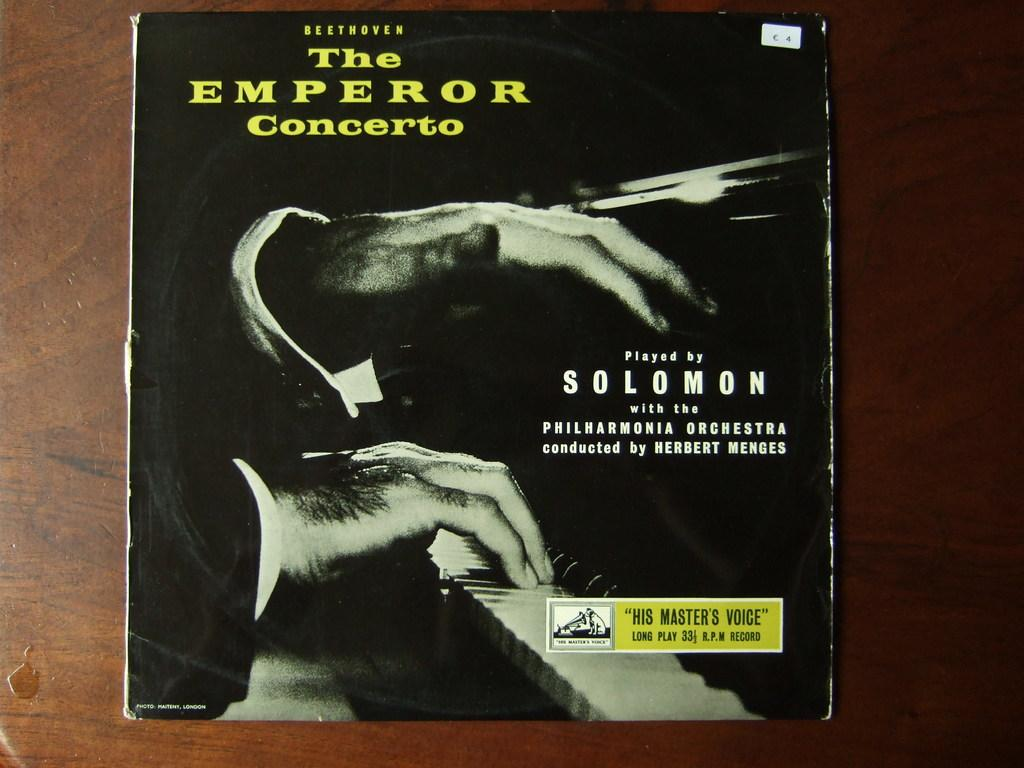<image>
Present a compact description of the photo's key features. The Album cover for Beethoven's The Emperor Concerto played by Solomon. 